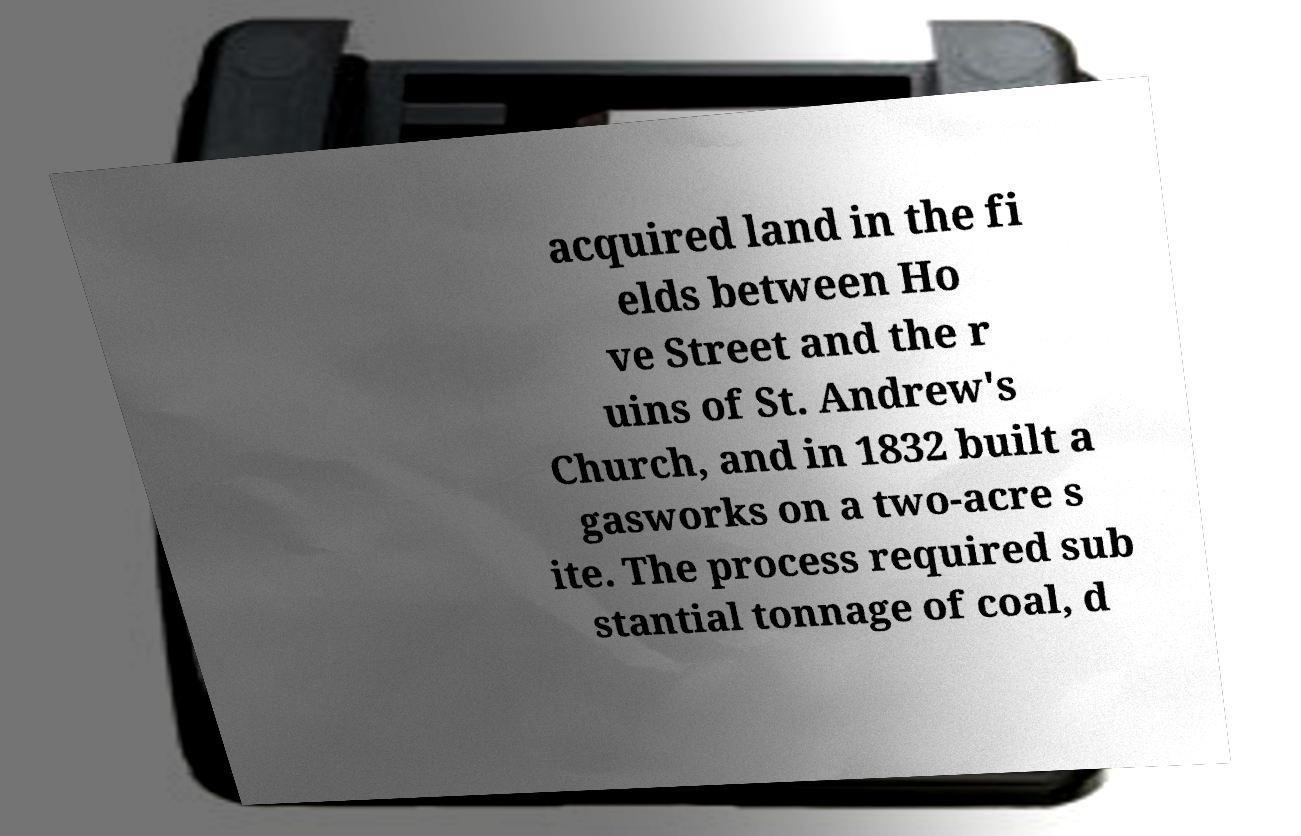Could you extract and type out the text from this image? acquired land in the fi elds between Ho ve Street and the r uins of St. Andrew's Church, and in 1832 built a gasworks on a two-acre s ite. The process required sub stantial tonnage of coal, d 